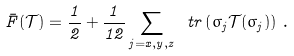Convert formula to latex. <formula><loc_0><loc_0><loc_500><loc_500>\bar { F } ( \mathcal { T } ) = \frac { 1 } { 2 } + \frac { 1 } { 1 2 } \sum _ { j = x , y , z } \ t r \left ( \sigma _ { j } \mathcal { T } ( \sigma _ { j } ) \right ) \, .</formula> 